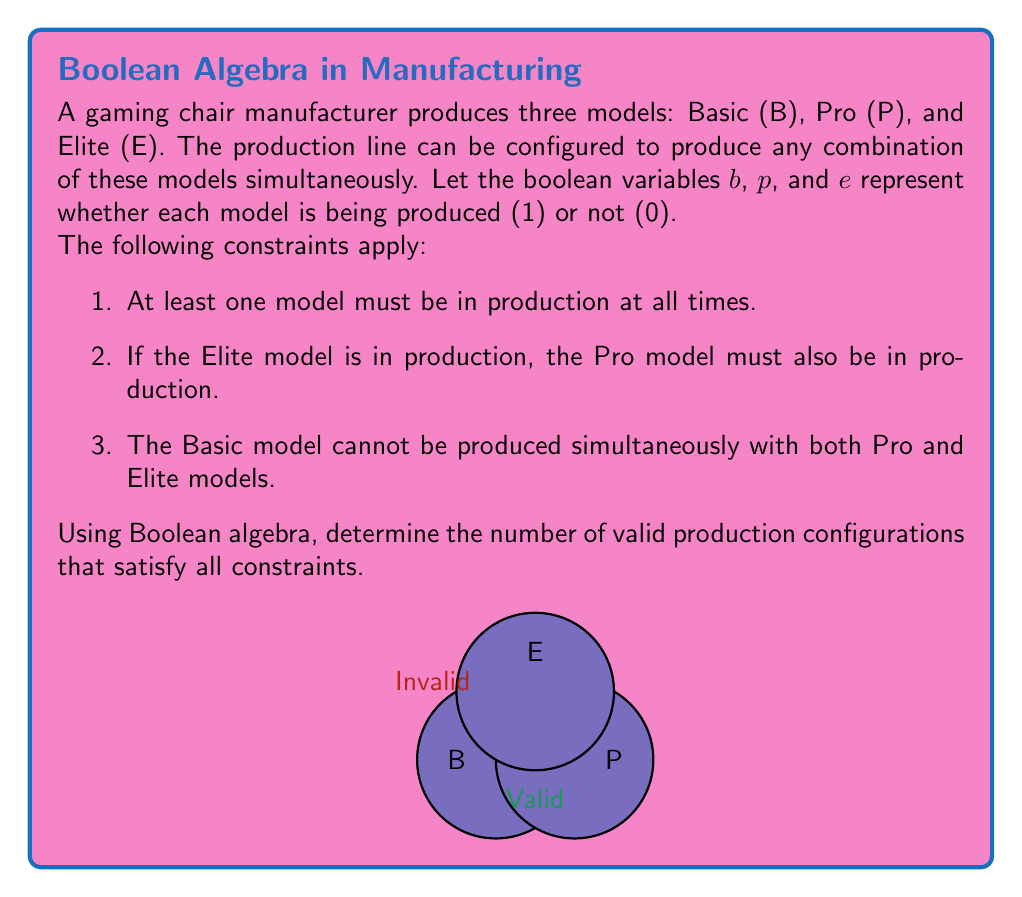Show me your answer to this math problem. Let's approach this step-by-step using Boolean algebra:

1) First, let's express the constraints as Boolean expressions:
   - At least one model in production: $b \lor p \lor e = 1$
   - Elite requires Pro: $e \implies p$ or $e \leq p$
   - Basic can't be with both Pro and Elite: $\lnot(b \land p \land e)$ or $\overline{bpe} = 1$

2) We can combine these constraints into a single Boolean expression:
   $f(b,p,e) = (b \lor p \lor e) \land (e \implies p) \land \overline{bpe}$

3) To find valid configurations, we need to find all combinations of $b$, $p$, and $e$ that make $f(b,p,e) = 1$

4) Let's evaluate $f(b,p,e)$ for all possible combinations:

   $f(0,0,0) = 0 \land 1 \land 1 = 0$
   $f(0,0,1) = 1 \land 0 \land 1 = 0$
   $f(0,1,0) = 1 \land 1 \land 1 = 1$
   $f(0,1,1) = 1 \land 1 \land 1 = 1$
   $f(1,0,0) = 1 \land 1 \land 1 = 1$
   $f(1,0,1) = 1 \land 0 \land 1 = 0$
   $f(1,1,0) = 1 \land 1 \land 1 = 1$
   $f(1,1,1) = 1 \land 1 \land 0 = 0$

5) Counting the number of combinations where $f(b,p,e) = 1$, we get 4 valid configurations.
Answer: 4 